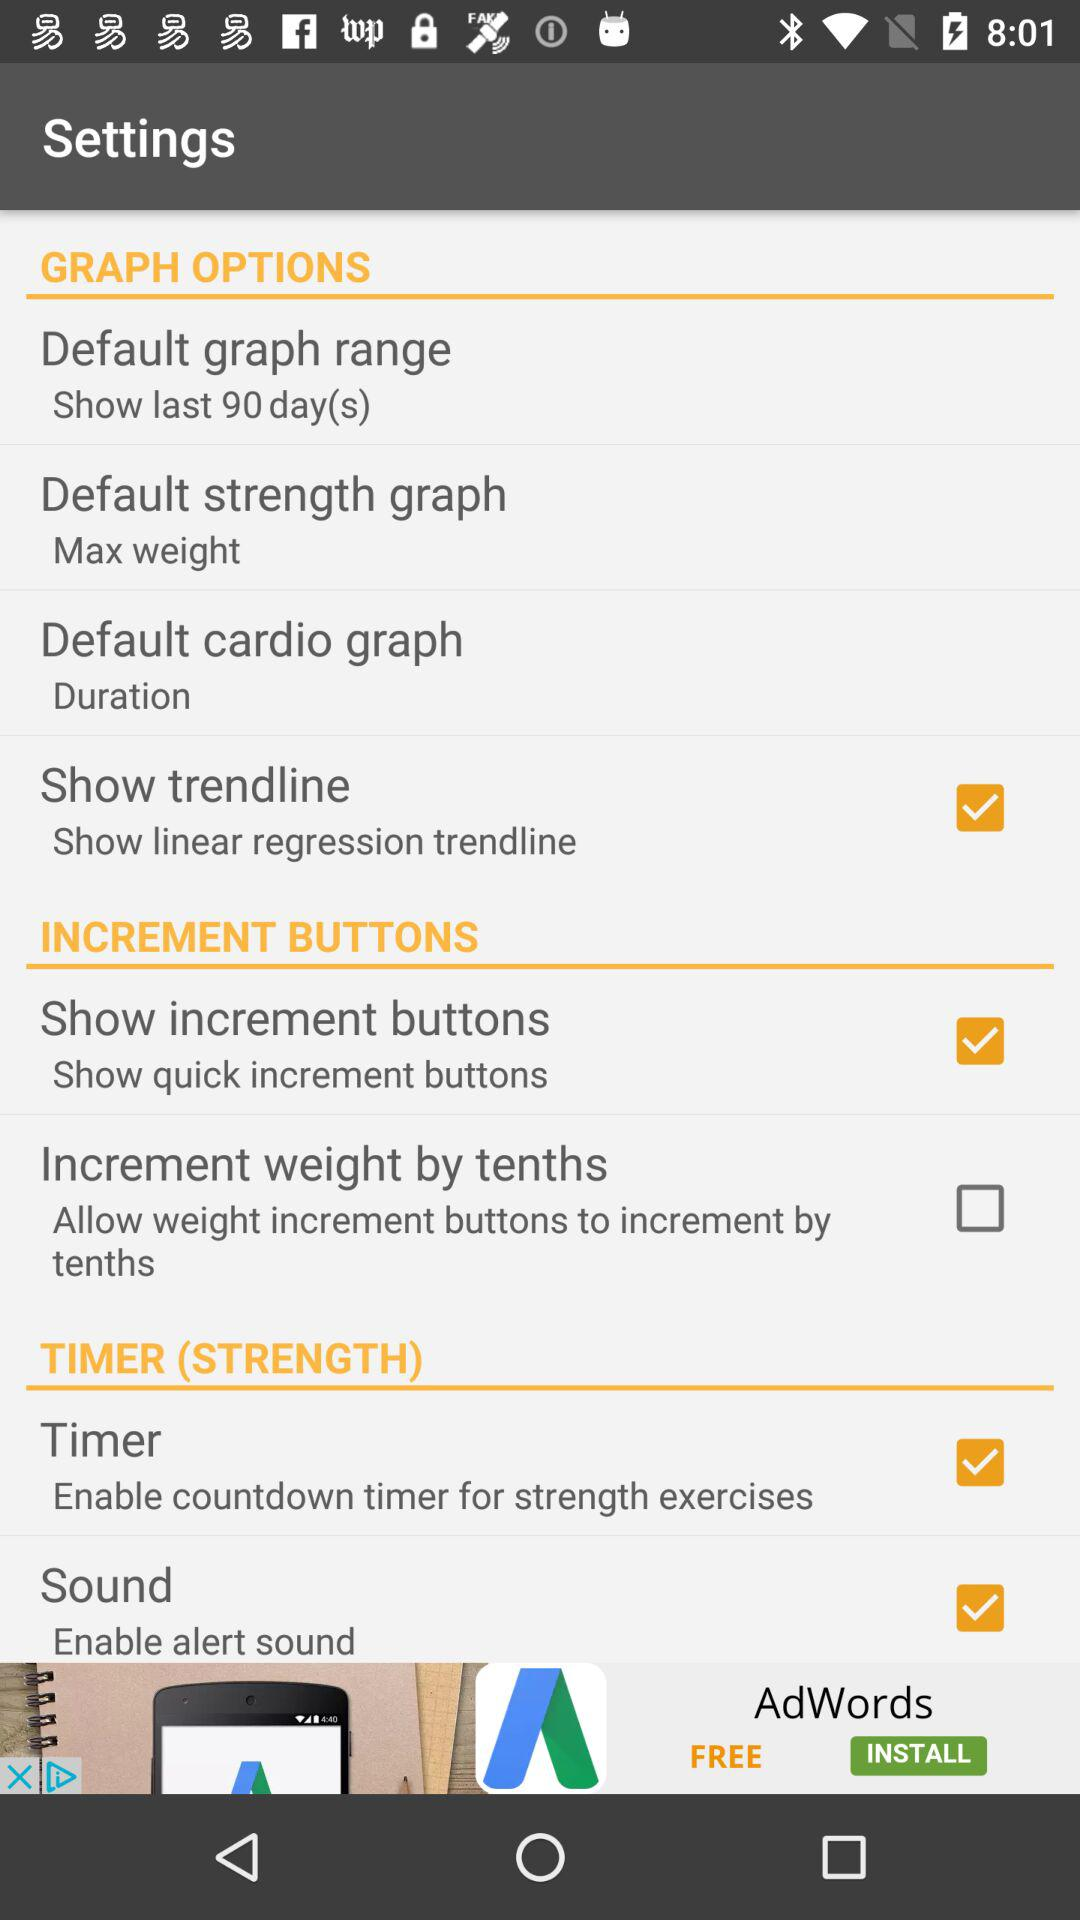What is the status of the timer? The status is on. 